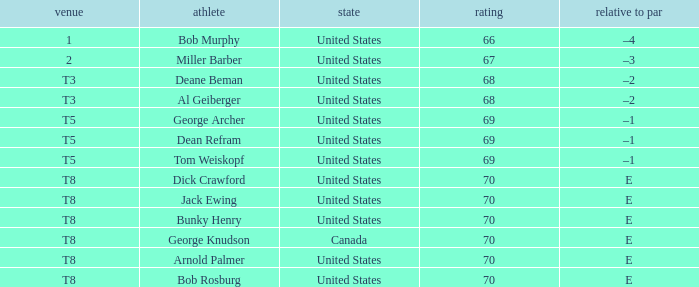In which nation does george archer hail from? United States. Could you parse the entire table as a dict? {'header': ['venue', 'athlete', 'state', 'rating', 'relative to par'], 'rows': [['1', 'Bob Murphy', 'United States', '66', '–4'], ['2', 'Miller Barber', 'United States', '67', '–3'], ['T3', 'Deane Beman', 'United States', '68', '–2'], ['T3', 'Al Geiberger', 'United States', '68', '–2'], ['T5', 'George Archer', 'United States', '69', '–1'], ['T5', 'Dean Refram', 'United States', '69', '–1'], ['T5', 'Tom Weiskopf', 'United States', '69', '–1'], ['T8', 'Dick Crawford', 'United States', '70', 'E'], ['T8', 'Jack Ewing', 'United States', '70', 'E'], ['T8', 'Bunky Henry', 'United States', '70', 'E'], ['T8', 'George Knudson', 'Canada', '70', 'E'], ['T8', 'Arnold Palmer', 'United States', '70', 'E'], ['T8', 'Bob Rosburg', 'United States', '70', 'E']]} 